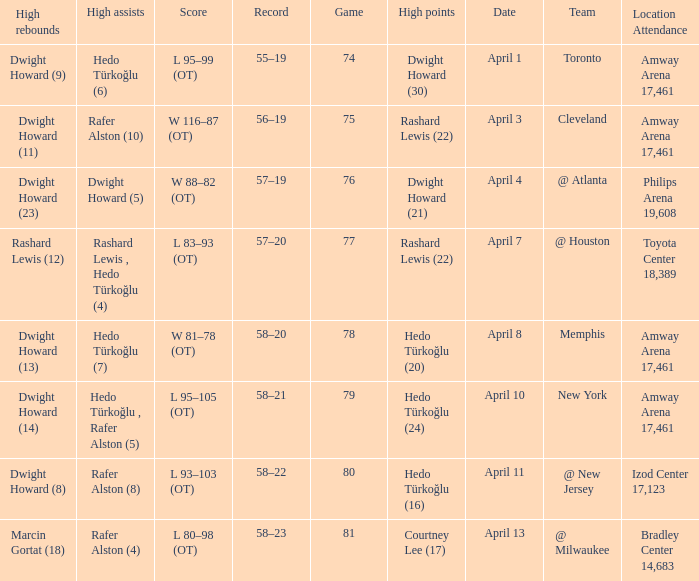Would you mind parsing the complete table? {'header': ['High rebounds', 'High assists', 'Score', 'Record', 'Game', 'High points', 'Date', 'Team', 'Location Attendance'], 'rows': [['Dwight Howard (9)', 'Hedo Türkoğlu (6)', 'L 95–99 (OT)', '55–19', '74', 'Dwight Howard (30)', 'April 1', 'Toronto', 'Amway Arena 17,461'], ['Dwight Howard (11)', 'Rafer Alston (10)', 'W 116–87 (OT)', '56–19', '75', 'Rashard Lewis (22)', 'April 3', 'Cleveland', 'Amway Arena 17,461'], ['Dwight Howard (23)', 'Dwight Howard (5)', 'W 88–82 (OT)', '57–19', '76', 'Dwight Howard (21)', 'April 4', '@ Atlanta', 'Philips Arena 19,608'], ['Rashard Lewis (12)', 'Rashard Lewis , Hedo Türkoğlu (4)', 'L 83–93 (OT)', '57–20', '77', 'Rashard Lewis (22)', 'April 7', '@ Houston', 'Toyota Center 18,389'], ['Dwight Howard (13)', 'Hedo Türkoğlu (7)', 'W 81–78 (OT)', '58–20', '78', 'Hedo Türkoğlu (20)', 'April 8', 'Memphis', 'Amway Arena 17,461'], ['Dwight Howard (14)', 'Hedo Türkoğlu , Rafer Alston (5)', 'L 95–105 (OT)', '58–21', '79', 'Hedo Türkoğlu (24)', 'April 10', 'New York', 'Amway Arena 17,461'], ['Dwight Howard (8)', 'Rafer Alston (8)', 'L 93–103 (OT)', '58–22', '80', 'Hedo Türkoğlu (16)', 'April 11', '@ New Jersey', 'Izod Center 17,123'], ['Marcin Gortat (18)', 'Rafer Alston (4)', 'L 80–98 (OT)', '58–23', '81', 'Courtney Lee (17)', 'April 13', '@ Milwaukee', 'Bradley Center 14,683']]} What was the score in game 81? L 80–98 (OT). 